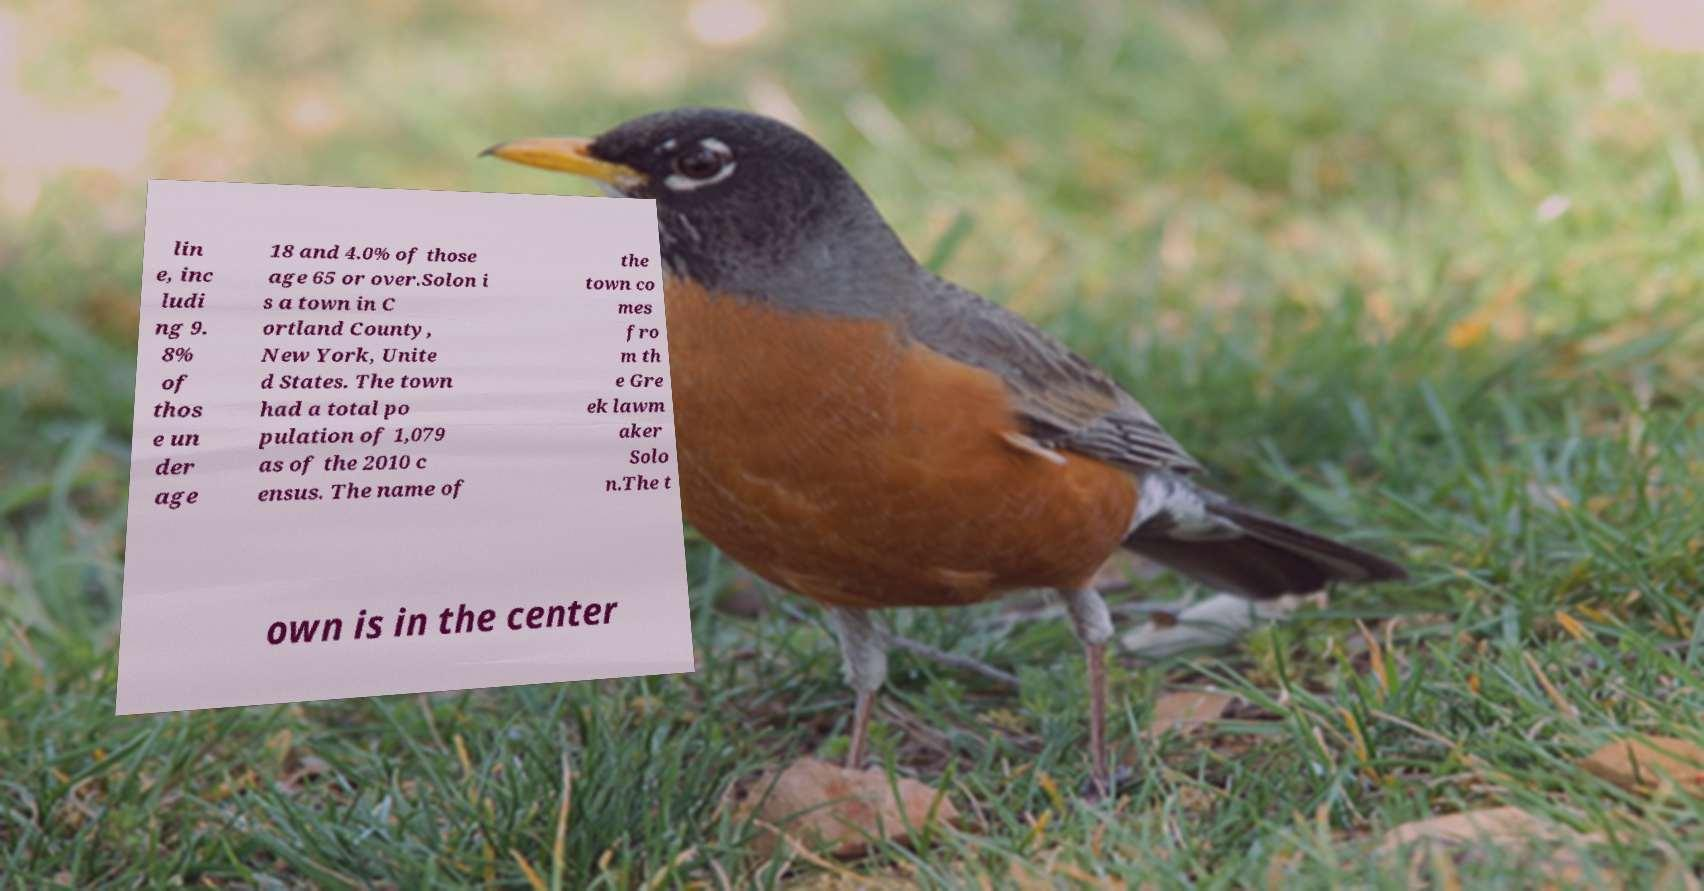Please identify and transcribe the text found in this image. lin e, inc ludi ng 9. 8% of thos e un der age 18 and 4.0% of those age 65 or over.Solon i s a town in C ortland County, New York, Unite d States. The town had a total po pulation of 1,079 as of the 2010 c ensus. The name of the town co mes fro m th e Gre ek lawm aker Solo n.The t own is in the center 